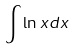<formula> <loc_0><loc_0><loc_500><loc_500>\int \ln x d x</formula> 